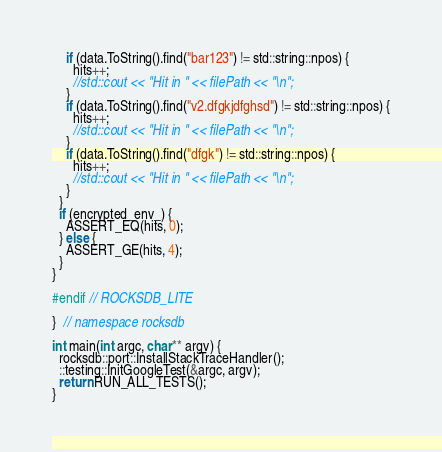<code> <loc_0><loc_0><loc_500><loc_500><_C++_>    if (data.ToString().find("bar123") != std::string::npos) {
      hits++; 
      //std::cout << "Hit in " << filePath << "\n";
    }
    if (data.ToString().find("v2.dfgkjdfghsd") != std::string::npos) {
      hits++; 
      //std::cout << "Hit in " << filePath << "\n";
    }
    if (data.ToString().find("dfgk") != std::string::npos) {
      hits++; 
      //std::cout << "Hit in " << filePath << "\n";
    }
  }
  if (encrypted_env_) {
    ASSERT_EQ(hits, 0);
  } else {
    ASSERT_GE(hits, 4);
  }
}

#endif // ROCKSDB_LITE

}  // namespace rocksdb

int main(int argc, char** argv) {
  rocksdb::port::InstallStackTraceHandler();
  ::testing::InitGoogleTest(&argc, argv);
  return RUN_ALL_TESTS();
}
</code> 